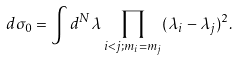Convert formula to latex. <formula><loc_0><loc_0><loc_500><loc_500>d \sigma _ { 0 } = \int d ^ { N } \lambda \prod _ { i < j ; m _ { i } = m _ { j } } ( \lambda _ { i } - \lambda _ { j } ) ^ { 2 } .</formula> 